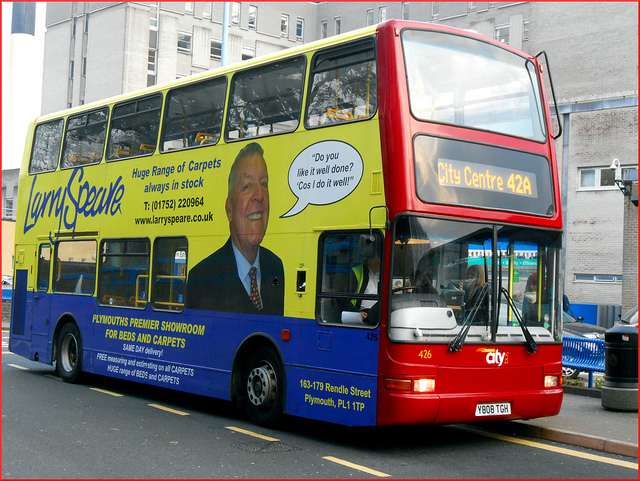<image>Which bus line is this? I don't know which bus line this is. It might be the '42a' or 'city center 42a'. Which bus line is this? I don't know which bus line this is. It can be either '42a' or 'city center 42a' or just 'city'. 